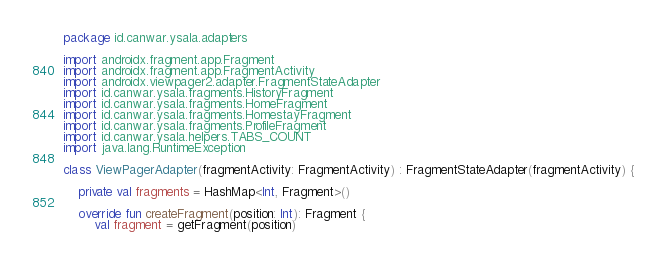Convert code to text. <code><loc_0><loc_0><loc_500><loc_500><_Kotlin_>package id.canwar.ysala.adapters

import androidx.fragment.app.Fragment
import androidx.fragment.app.FragmentActivity
import androidx.viewpager2.adapter.FragmentStateAdapter
import id.canwar.ysala.fragments.HistoryFragment
import id.canwar.ysala.fragments.HomeFragment
import id.canwar.ysala.fragments.HomestayFragment
import id.canwar.ysala.fragments.ProfileFragment
import id.canwar.ysala.helpers.TABS_COUNT
import java.lang.RuntimeException

class ViewPagerAdapter(fragmentActivity: FragmentActivity) : FragmentStateAdapter(fragmentActivity) {

    private val fragments = HashMap<Int, Fragment>()

    override fun createFragment(position: Int): Fragment {
        val fragment = getFragment(position)</code> 